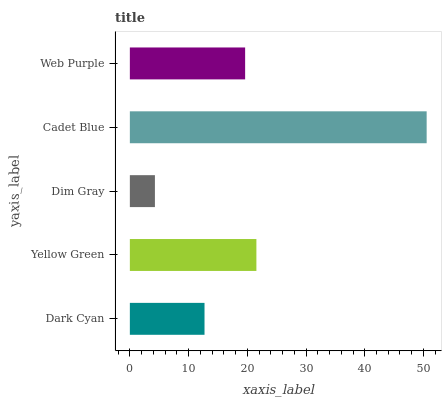Is Dim Gray the minimum?
Answer yes or no. Yes. Is Cadet Blue the maximum?
Answer yes or no. Yes. Is Yellow Green the minimum?
Answer yes or no. No. Is Yellow Green the maximum?
Answer yes or no. No. Is Yellow Green greater than Dark Cyan?
Answer yes or no. Yes. Is Dark Cyan less than Yellow Green?
Answer yes or no. Yes. Is Dark Cyan greater than Yellow Green?
Answer yes or no. No. Is Yellow Green less than Dark Cyan?
Answer yes or no. No. Is Web Purple the high median?
Answer yes or no. Yes. Is Web Purple the low median?
Answer yes or no. Yes. Is Dim Gray the high median?
Answer yes or no. No. Is Dark Cyan the low median?
Answer yes or no. No. 